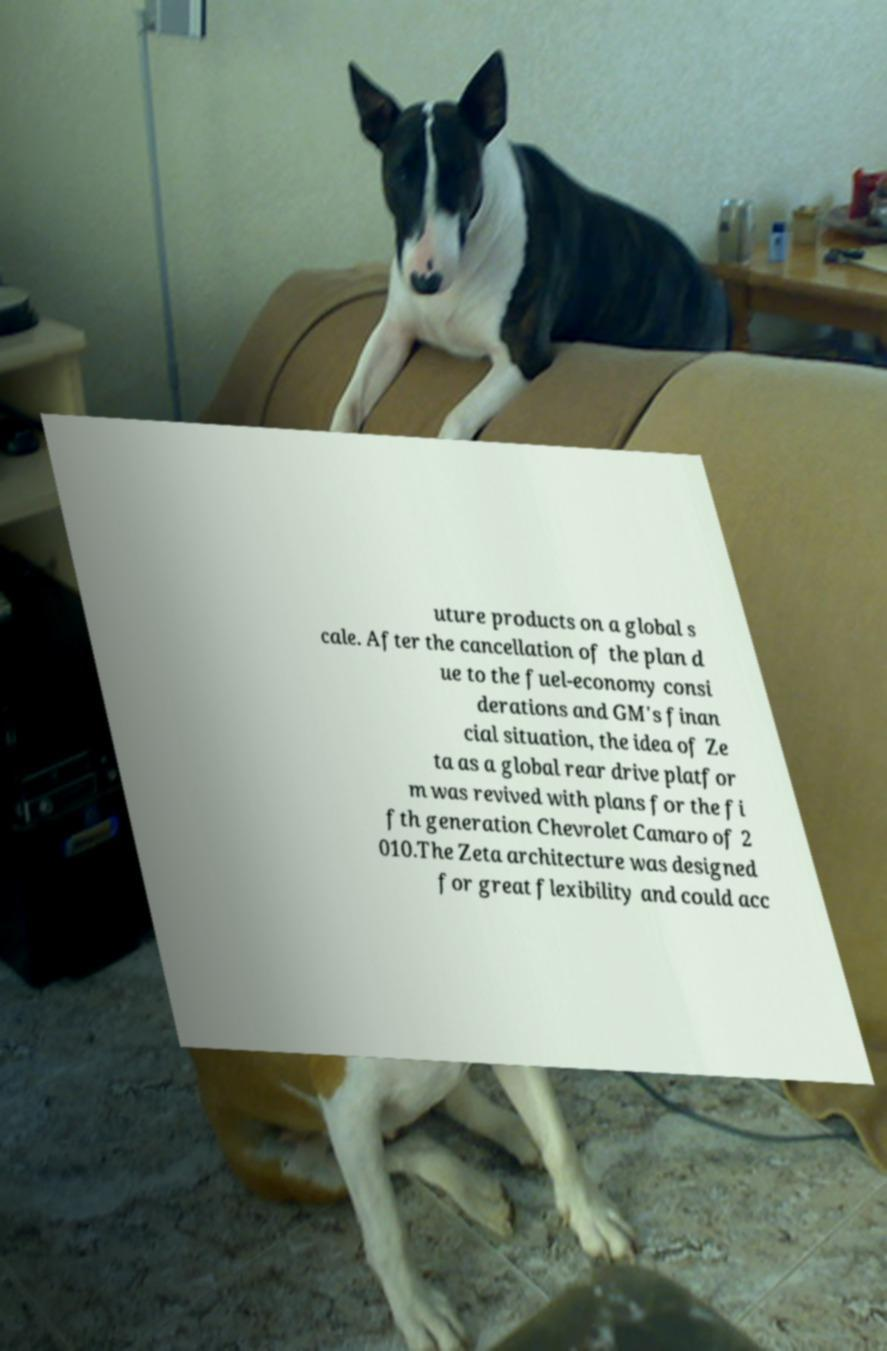Could you extract and type out the text from this image? uture products on a global s cale. After the cancellation of the plan d ue to the fuel-economy consi derations and GM's finan cial situation, the idea of Ze ta as a global rear drive platfor m was revived with plans for the fi fth generation Chevrolet Camaro of 2 010.The Zeta architecture was designed for great flexibility and could acc 